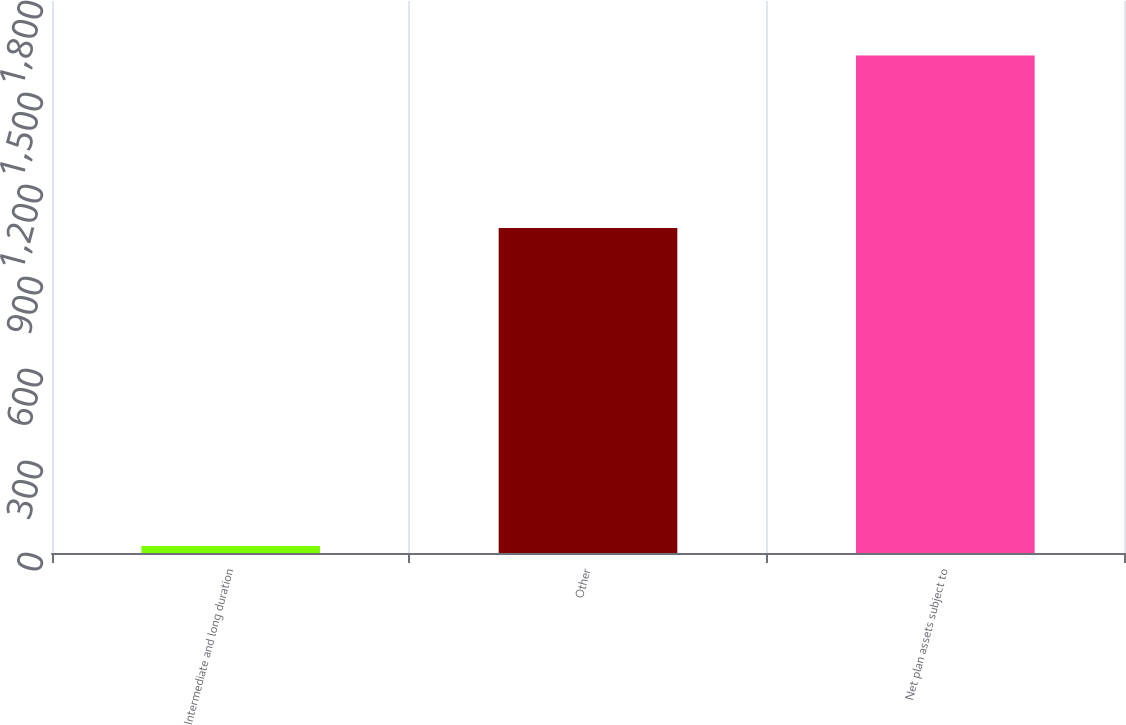Convert chart. <chart><loc_0><loc_0><loc_500><loc_500><bar_chart><fcel>Intermediate and long duration<fcel>Other<fcel>Net plan assets subject to<nl><fcel>23<fcel>1060<fcel>1622<nl></chart> 